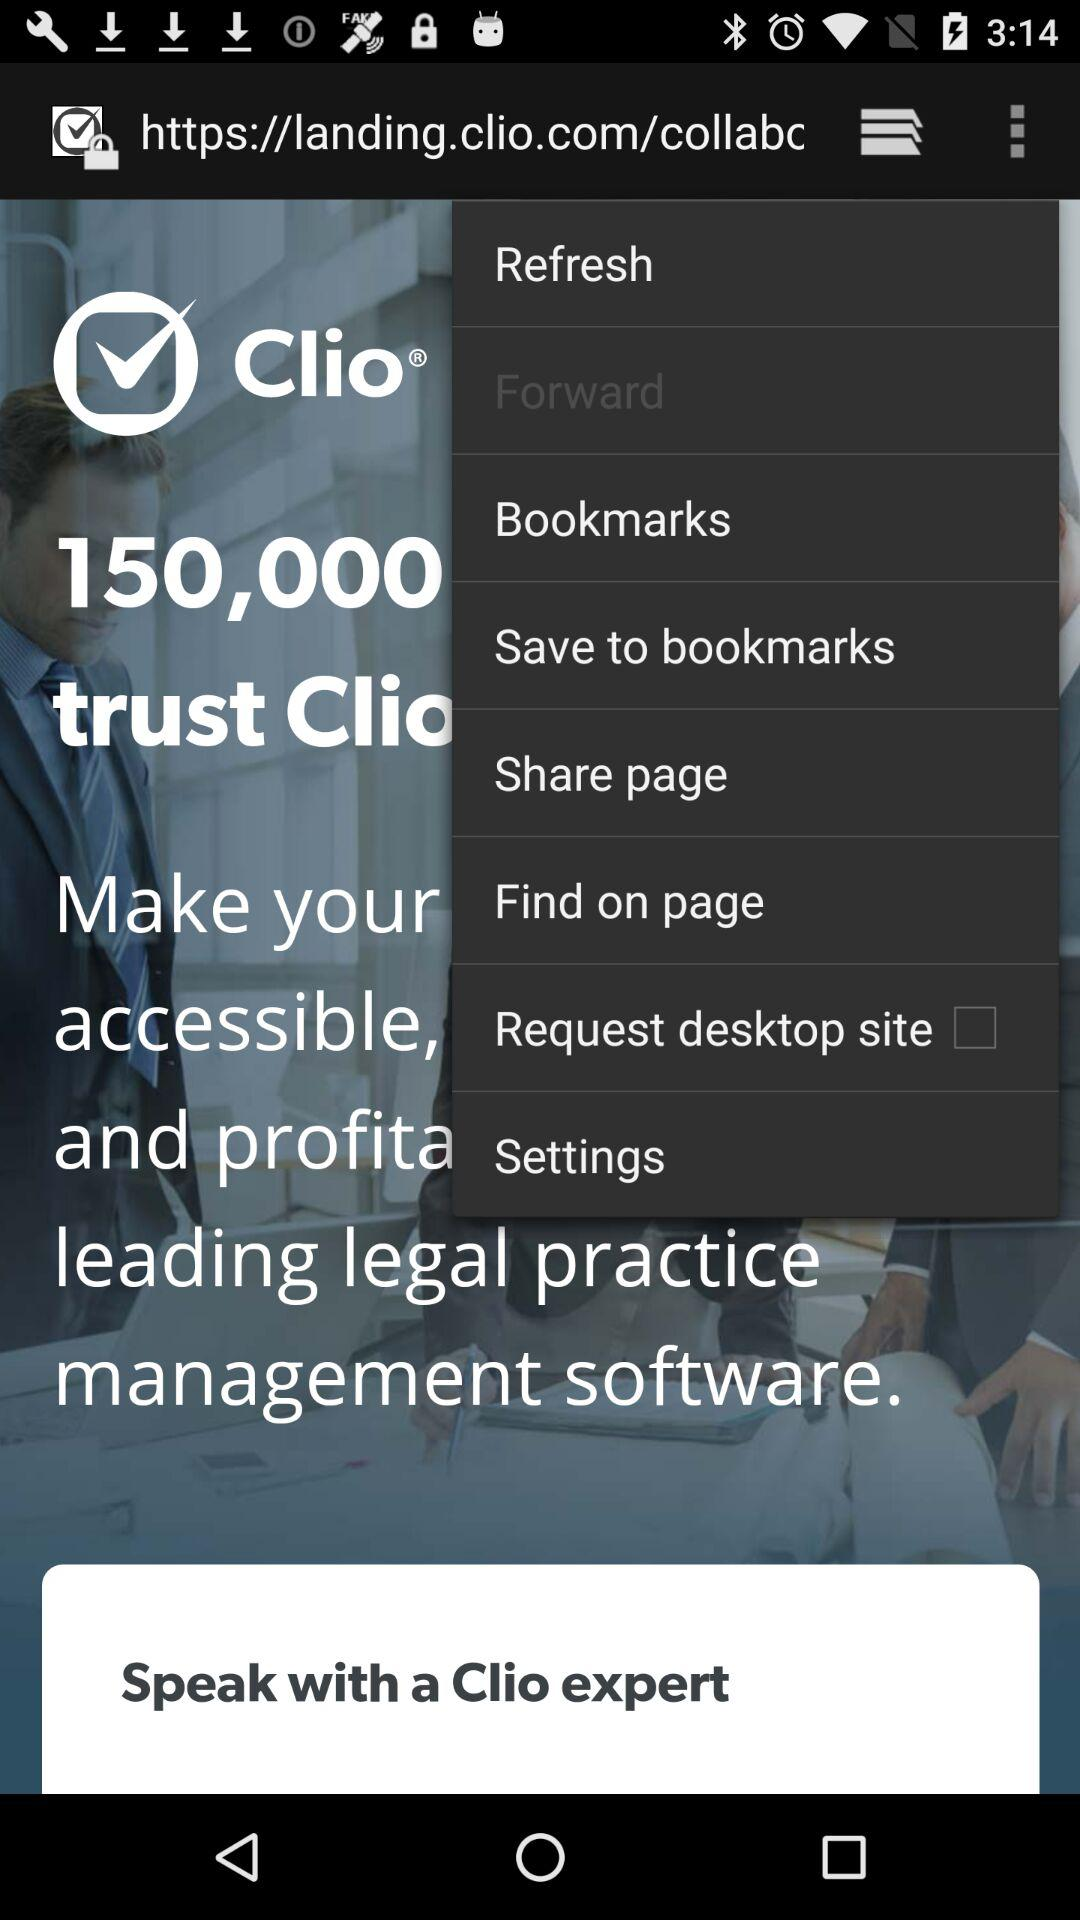What is the status of the "Request desktop site"? The status of the "Request desktop site" is "off". 